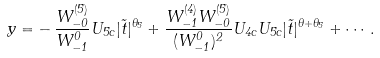Convert formula to latex. <formula><loc_0><loc_0><loc_500><loc_500>y = - \, \frac { W _ { - 0 } ^ { ( 5 ) } } { W _ { - 1 } ^ { 0 } } U _ { 5 c } | \tilde { t } | ^ { \theta _ { 5 } } + \frac { W _ { - 1 } ^ { ( 4 ) } W _ { - 0 } ^ { ( 5 ) } } { ( W _ { - 1 } ^ { 0 } ) ^ { 2 } } U _ { 4 c } U _ { 5 c } | \tilde { t } | ^ { \theta + \theta _ { 5 } } + \cdots .</formula> 